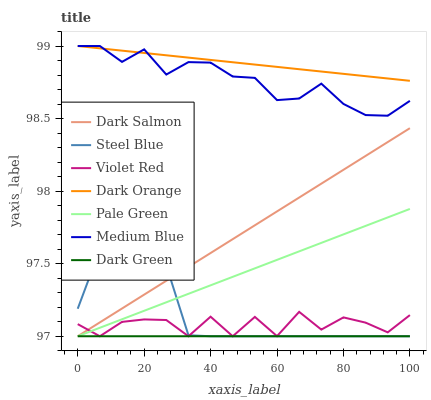Does Dark Green have the minimum area under the curve?
Answer yes or no. Yes. Does Dark Orange have the maximum area under the curve?
Answer yes or no. Yes. Does Violet Red have the minimum area under the curve?
Answer yes or no. No. Does Violet Red have the maximum area under the curve?
Answer yes or no. No. Is Dark Green the smoothest?
Answer yes or no. Yes. Is Violet Red the roughest?
Answer yes or no. Yes. Is Medium Blue the smoothest?
Answer yes or no. No. Is Medium Blue the roughest?
Answer yes or no. No. Does Violet Red have the lowest value?
Answer yes or no. Yes. Does Medium Blue have the lowest value?
Answer yes or no. No. Does Medium Blue have the highest value?
Answer yes or no. Yes. Does Violet Red have the highest value?
Answer yes or no. No. Is Violet Red less than Dark Orange?
Answer yes or no. Yes. Is Medium Blue greater than Pale Green?
Answer yes or no. Yes. Does Medium Blue intersect Dark Orange?
Answer yes or no. Yes. Is Medium Blue less than Dark Orange?
Answer yes or no. No. Is Medium Blue greater than Dark Orange?
Answer yes or no. No. Does Violet Red intersect Dark Orange?
Answer yes or no. No. 